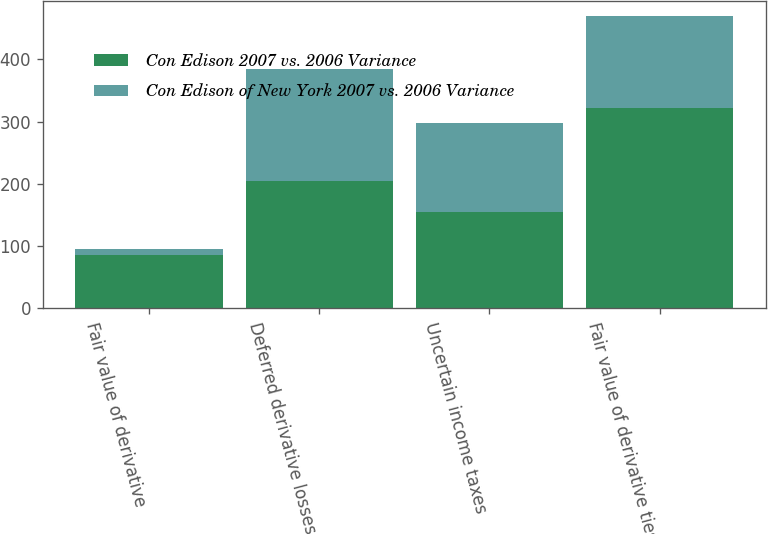<chart> <loc_0><loc_0><loc_500><loc_500><stacked_bar_chart><ecel><fcel>Fair value of derivative<fcel>Deferred derivative losses<fcel>Uncertain income taxes<fcel>Fair value of derivative ties<nl><fcel>Con Edison 2007 vs. 2006 Variance<fcel>86<fcel>205<fcel>155<fcel>322<nl><fcel>Con Edison of New York 2007 vs. 2006 Variance<fcel>10<fcel>180<fcel>142<fcel>148<nl></chart> 